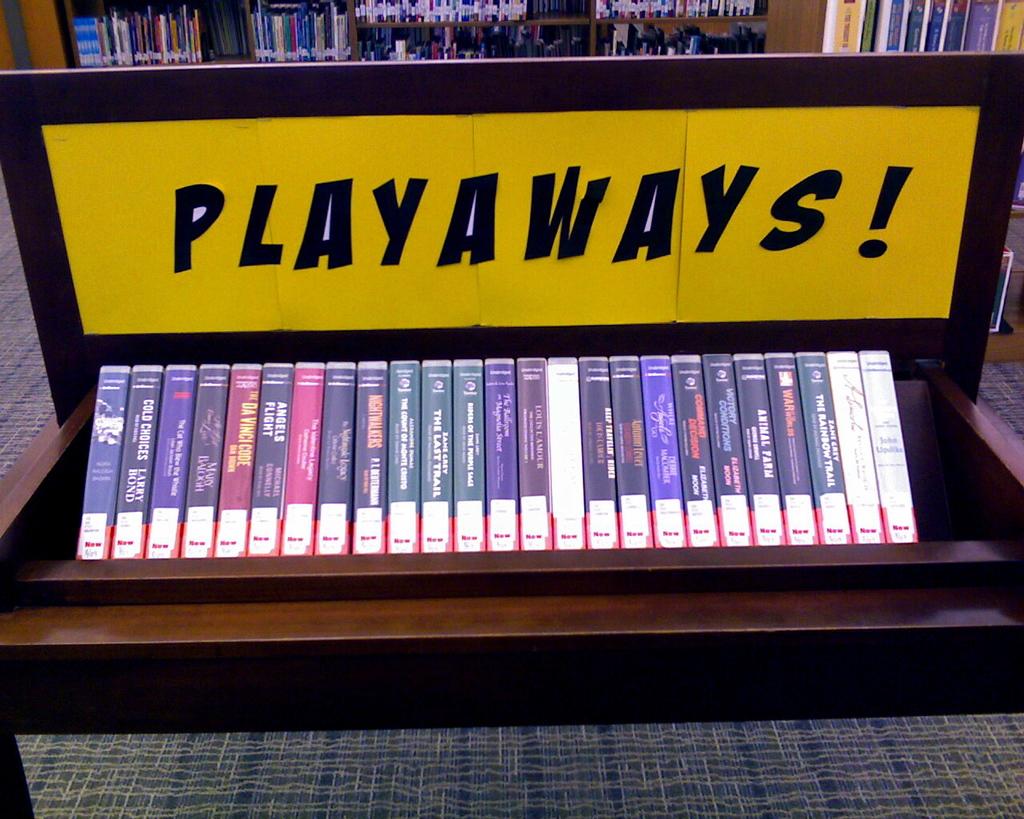What does the sign say?
Your response must be concise. Playaways!. What is written on any of the cases shown?
Your answer should be compact. Angels flight. 